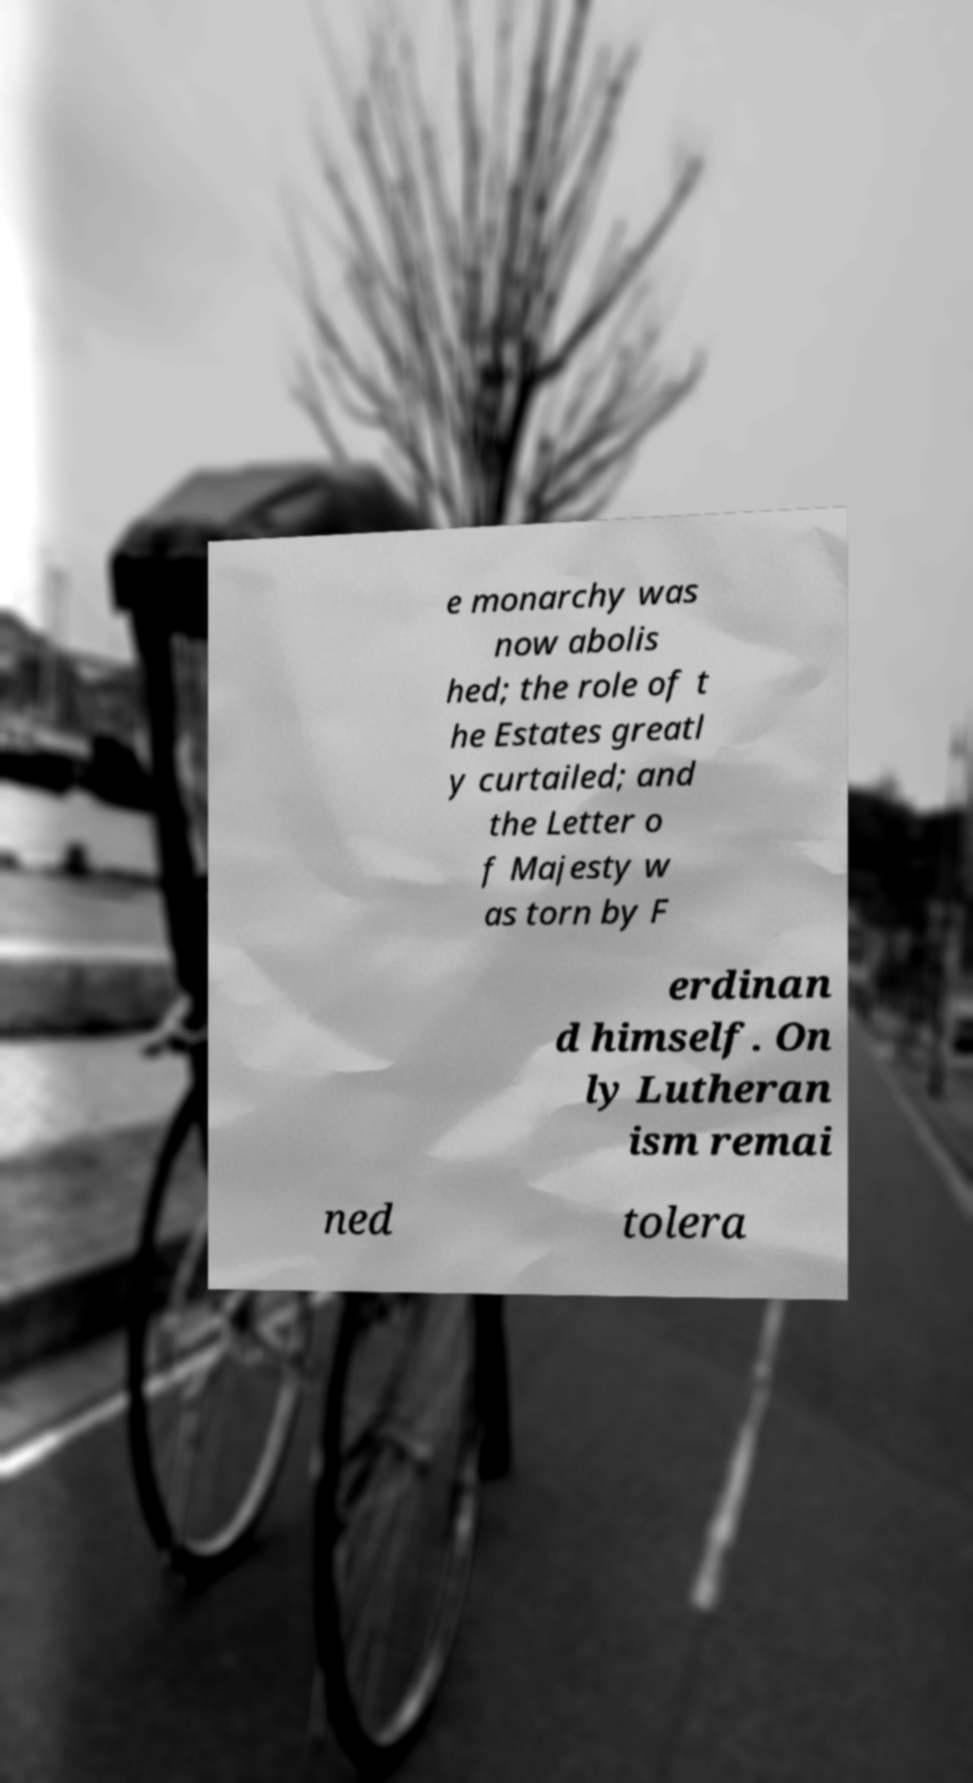Please identify and transcribe the text found in this image. e monarchy was now abolis hed; the role of t he Estates greatl y curtailed; and the Letter o f Majesty w as torn by F erdinan d himself. On ly Lutheran ism remai ned tolera 